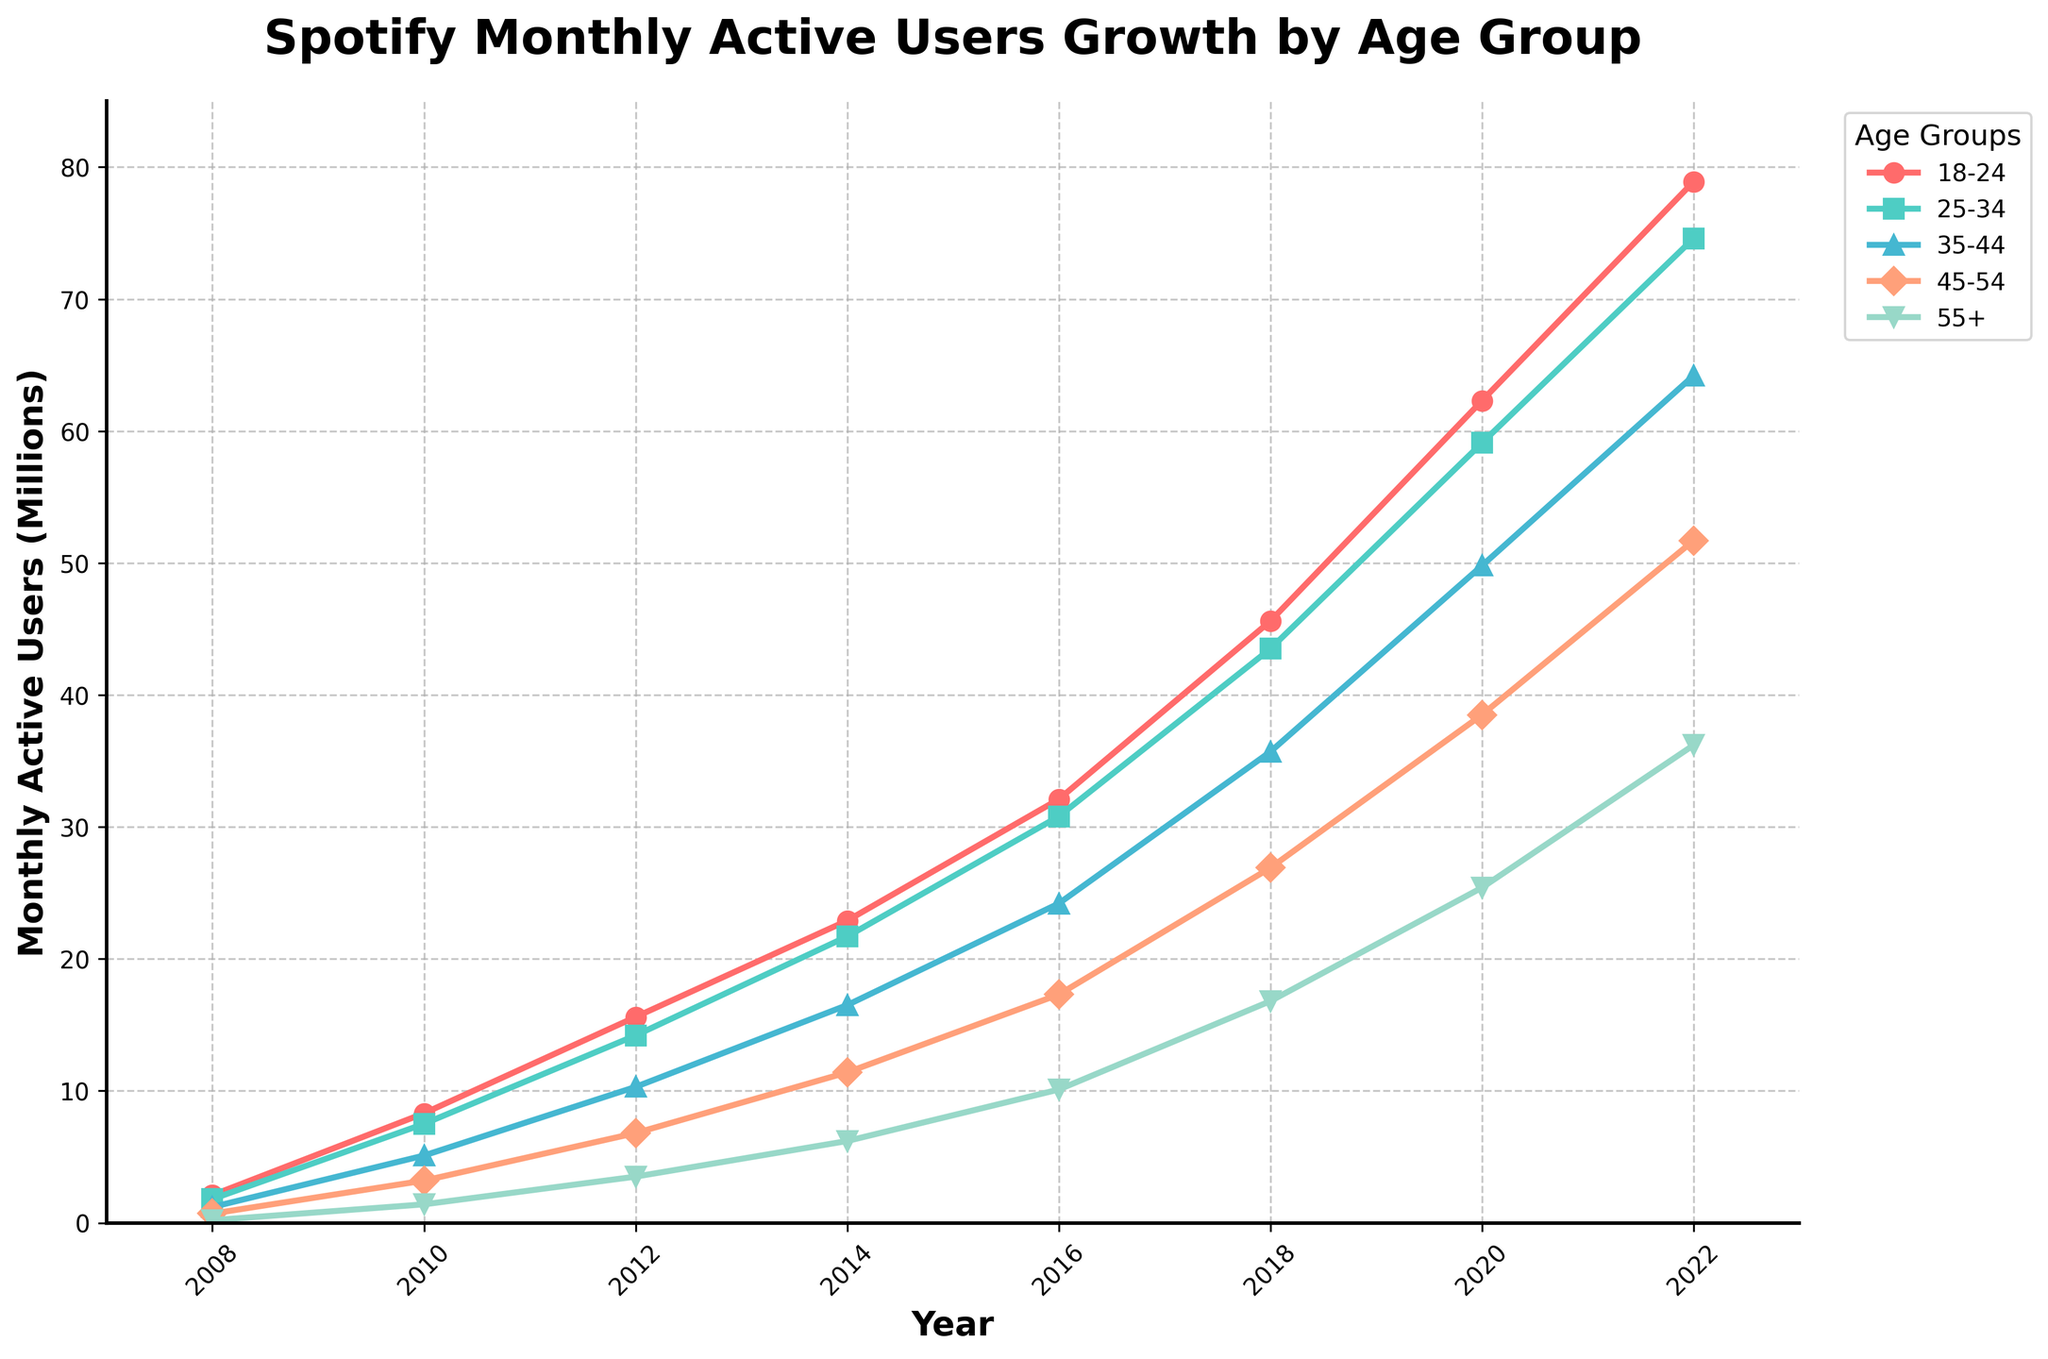What's the total number of monthly active users across all age groups in 2022? First, identify the number of users for each age group in 2022 from the plot (78.9, 74.6, 64.2, 51.7, and 36.2 million). Add them together: 78.9 + 74.6 + 64.2 + 51.7 + 36.2 = 305.6 million.
Answer: 305.6 million Which age group had the fastest growth rate between 2008 and 2022? Identify the number of users in 2008 and 2022 for each age group and calculate the difference. For instance, for the 18-24 age group, the difference is 78.9 - 2.1 = 76.8. Repeat this process for each age group and compare the differences. The 18-24 age group had the biggest increase (76.8 million).
Answer: 18-24 Which two age groups had the smallest difference in growth between 2018 and 2020? Determine the number of users for each age group in 2018 and 2020 and then calculate the differences. For example, for the 18-24 age group, the difference is 62.3 - 45.6 = 16.7. Perform similar calculations for all other age groups and compare the differences to find the two smallest ones. The 35-44 (14.1) and 25-34 (15.6) had the smallest differences.
Answer: 35-44, 25-34 What is the average number of monthly active users across all age groups in 2014? Identify the number of users for each age group in 2014 (22.9, 21.7, 16.5, 11.4, and 6.2 million). Calculate the average by adding them and then dividing by the number of age groups: (22.9 + 21.7 + 16.5 + 11.4 + 6.2) / 5 = 15.74 million.
Answer: 15.74 million Which age group had the least number of monthly active users in 2016? Identify the number of users for each age group in 2016 from the plot and find the smallest number. The 55+ age group had the smallest number with 10.1 million users.
Answer: 55+ How much did the number of users for the 35-44 age group increase from 2008 to 2016? Identify the number of users in 2008 and 2016 for the 35-44 age group. Then, calculate the difference: 24.2 - 1.2 = 23 million.
Answer: 23 million Which age group's number of users did not exceed 50 million in any year? Identify each age group's user numbers across all the years and check which one never exceeded 50 million. The 55+ age group never exceeded 50 million users in any year.
Answer: 55+ 